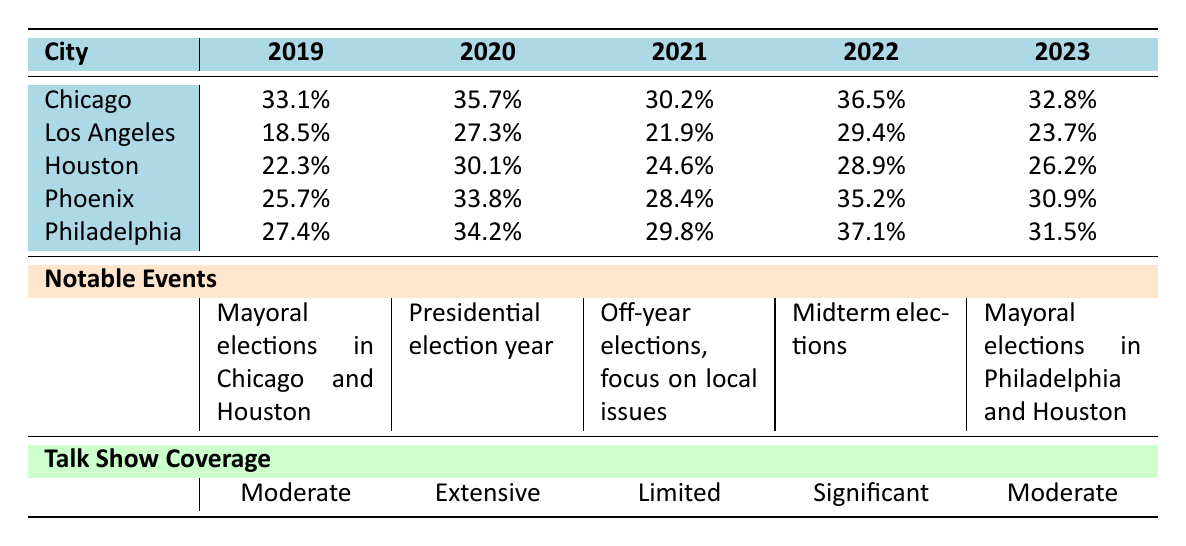What was the voter turnout in Los Angeles in 2022? According to the table, the voter turnout in Los Angeles for the year 2022 is listed as 29.4%.
Answer: 29.4% Which city had the highest voter turnout in 2023? The table shows that in 2023, Philadelphia had the highest voter turnout at 31.5% compared to the other cities.
Answer: Philadelphia What was the average voter turnout for Phoenix over the past 5 years? For Phoenix, the voter turnouts from 2019 to 2023 are 25.7%, 33.8%, 28.4%, 35.2%, and 30.9%. The sum is 154.0%. Dividing by 5 gives an average of 30.8%.
Answer: 30.8% Did voter turnout in Chicago decrease between 2021 and 2022? The table indicates that Chicago's voter turnout was 30.2% in 2021 and increased to 36.5% in 2022. Thus, it did not decrease but rather increased.
Answer: No Which city consistently had the lowest voter turnout over the 5 years? The table shows the voter turnout for Los Angeles is consistently lower than others: 18.5%, 27.3%, 21.9%, 29.4%, and 23.7%, making it the city with the lowest turnout throughout the period.
Answer: Los Angeles How much did voter turnout increase in Philadelphia from 2019 to 2022? The turnout in Philadelphia was 27.4% in 2019 and rose to 37.1% in 2022. The increase is 37.1% - 27.4% = 9.7%.
Answer: 9.7% True or False: Voter outreach initiatives in Houston included door-to-door canvassing. The table indicates that Houston's voter outreach initiatives were "Text message reminders" and "Multilingual outreach," so door-to-door canvassing was not included.
Answer: False What was the notable event in the year 2020 and how did it relate to voter turnout? The table states that 2020 was a presidential election year, which typically leads to higher voter turnout. This is reflected in the voter turnout of cities during this year, including a turnout of 27.3% in Los Angeles.
Answer: Presidential election year, likely higher turnout 